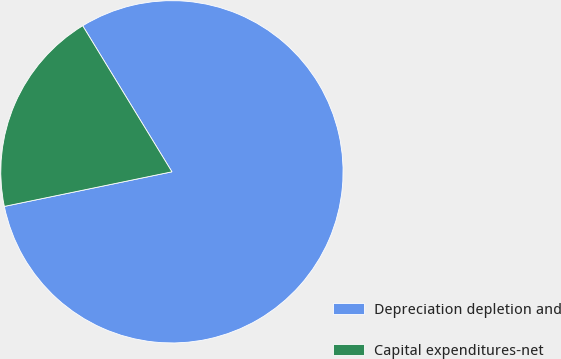Convert chart to OTSL. <chart><loc_0><loc_0><loc_500><loc_500><pie_chart><fcel>Depreciation depletion and<fcel>Capital expenditures-net<nl><fcel>80.49%<fcel>19.51%<nl></chart> 